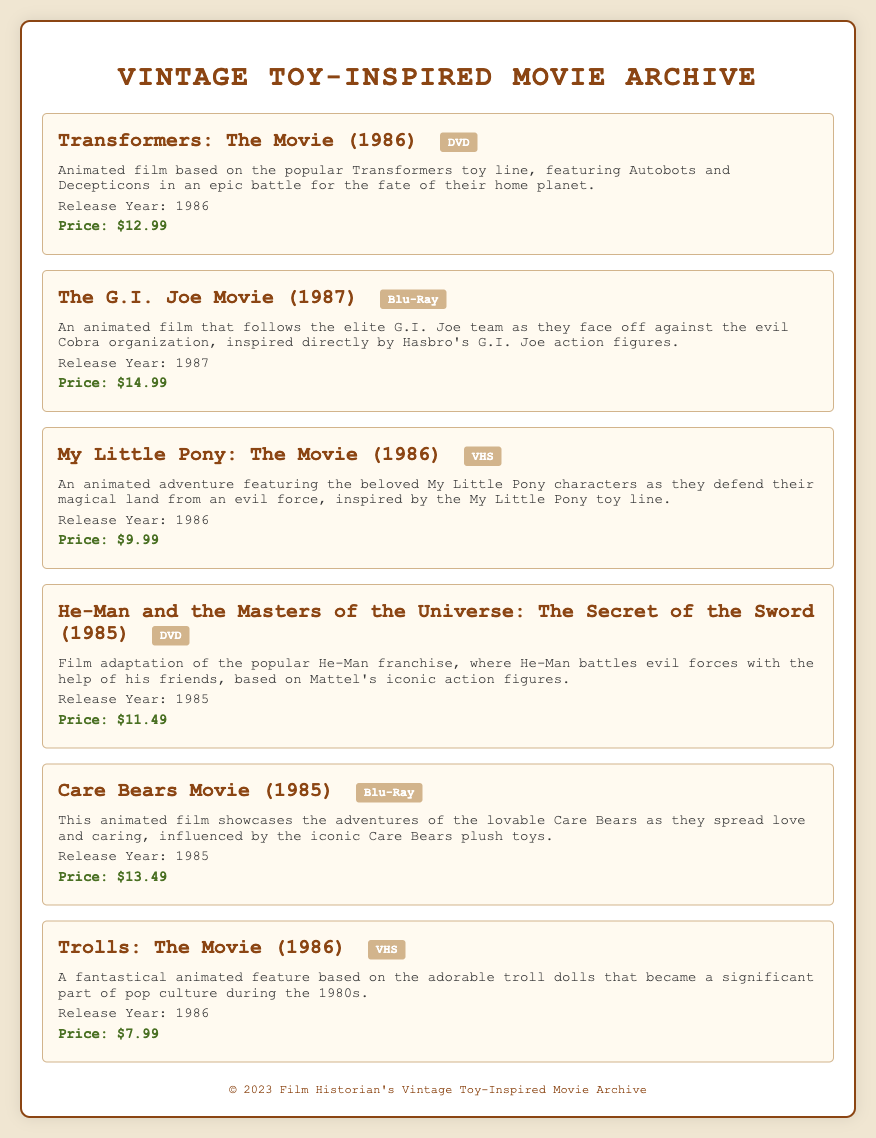what is the price of Transformers: The Movie? The price of Transformers: The Movie is listed in the document as $12.99.
Answer: $12.99 which format is The G.I. Joe Movie available in? The document specifies that The G.I. Joe Movie is available in Blu-Ray format.
Answer: Blu-Ray how many movies in the archive were released in 1986? The document lists three movies released in 1986: Transformers: The Movie, My Little Pony: The Movie, and Trolls: The Movie.
Answer: 3 what year was Care Bears Movie released? According to the document, Care Bears Movie was released in 1985.
Answer: 1985 which movie features He-Man? The movie featuring He-Man is titled He-Man and the Masters of the Universe: The Secret of the Sword.
Answer: He-Man and the Masters of the Universe: The Secret of the Sword what item type is My Little Pony: The Movie? The document states that My Little Pony: The Movie is available in VHS format.
Answer: VHS which movie has the highest price in the archive? The highest price listed in the archive is for The G.I. Joe Movie, which is $14.99.
Answer: $14.99 what is the common theme of the movies in this archive? The common theme of the movies in this archive is that they are inspired by popular toy lines from the 1980s.
Answer: Inspired by 1980s toy lines 